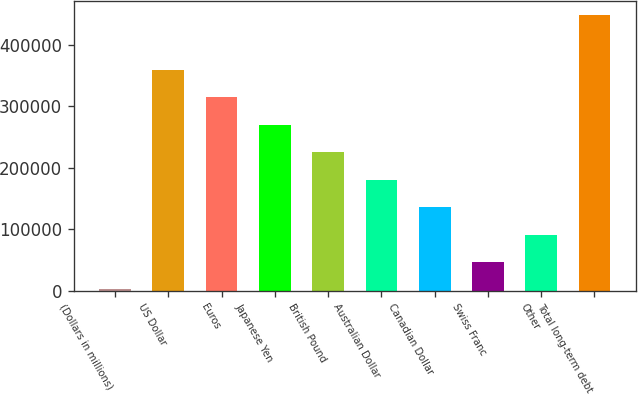<chart> <loc_0><loc_0><loc_500><loc_500><bar_chart><fcel>(Dollars in millions)<fcel>US Dollar<fcel>Euros<fcel>Japanese Yen<fcel>British Pound<fcel>Australian Dollar<fcel>Canadian Dollar<fcel>Swiss Franc<fcel>Other<fcel>Total long-term debt<nl><fcel>2010<fcel>359147<fcel>314505<fcel>269863<fcel>225220<fcel>180578<fcel>135936<fcel>46652.1<fcel>91294.2<fcel>448431<nl></chart> 